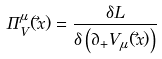Convert formula to latex. <formula><loc_0><loc_0><loc_500><loc_500>\Pi ^ { \mu } _ { V } ( { \vec { x } } ) = \frac { \delta { L } } { \delta \left ( \partial _ { + } V _ { \mu } ( \vec { x } ) \right ) }</formula> 